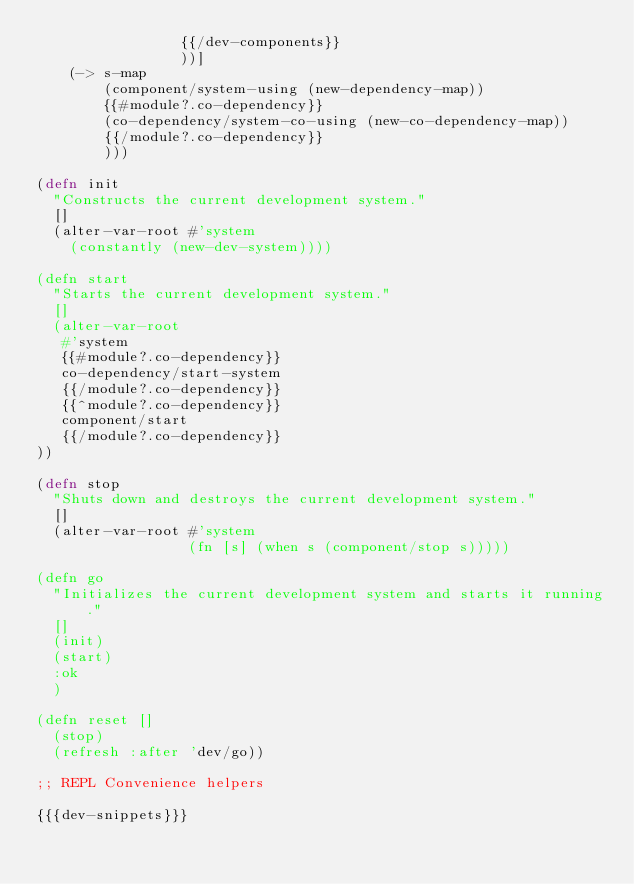Convert code to text. <code><loc_0><loc_0><loc_500><loc_500><_Clojure_>                 {{/dev-components}}
                 ))]
    (-> s-map
        (component/system-using (new-dependency-map))
        {{#module?.co-dependency}}
        (co-dependency/system-co-using (new-co-dependency-map))
        {{/module?.co-dependency}}
        )))

(defn init
  "Constructs the current development system."
  []
  (alter-var-root #'system
    (constantly (new-dev-system))))

(defn start
  "Starts the current development system."
  []
  (alter-var-root
   #'system
   {{#module?.co-dependency}}
   co-dependency/start-system
   {{/module?.co-dependency}}
   {{^module?.co-dependency}}
   component/start
   {{/module?.co-dependency}}
))

(defn stop
  "Shuts down and destroys the current development system."
  []
  (alter-var-root #'system
                  (fn [s] (when s (component/stop s)))))

(defn go
  "Initializes the current development system and starts it running."
  []
  (init)
  (start)
  :ok
  )

(defn reset []
  (stop)
  (refresh :after 'dev/go))

;; REPL Convenience helpers

{{{dev-snippets}}}
</code> 